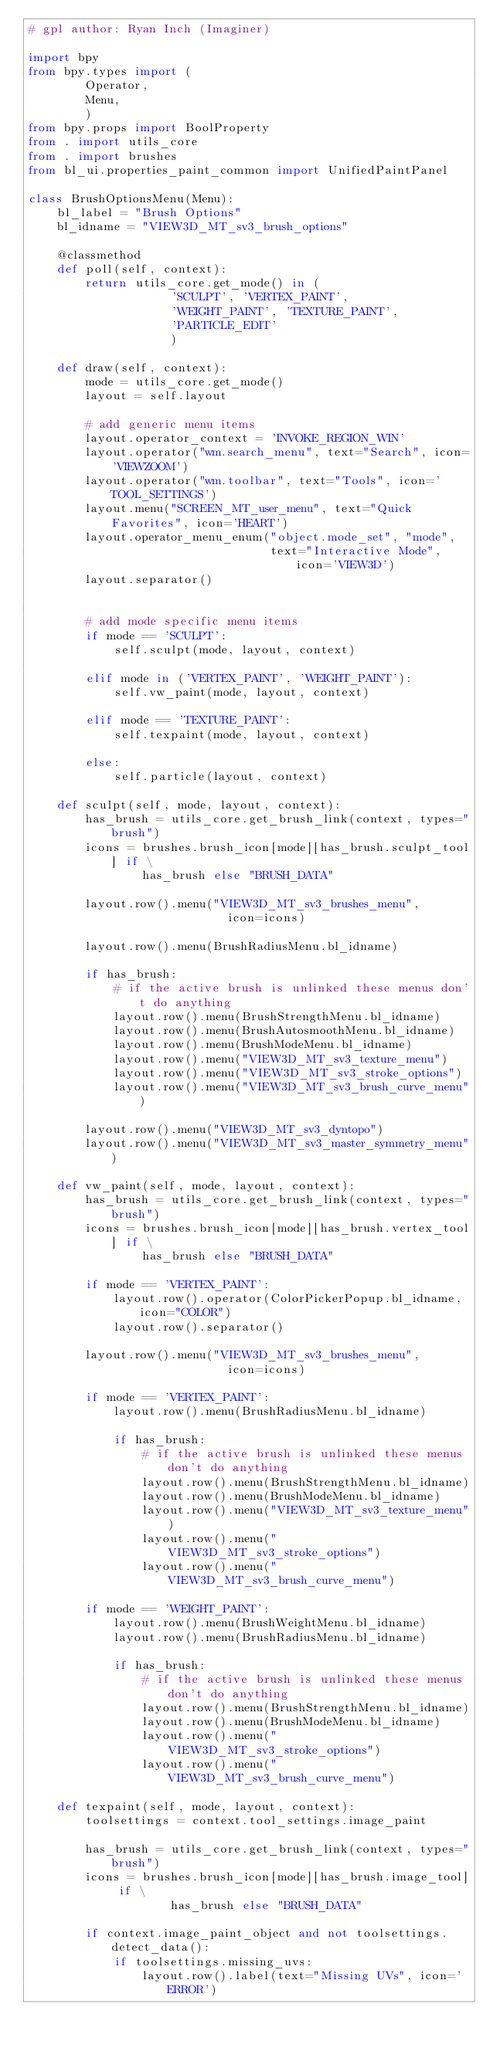<code> <loc_0><loc_0><loc_500><loc_500><_Python_># gpl author: Ryan Inch (Imaginer)

import bpy
from bpy.types import (
        Operator,
        Menu,
        )
from bpy.props import BoolProperty
from . import utils_core
from . import brushes
from bl_ui.properties_paint_common import UnifiedPaintPanel

class BrushOptionsMenu(Menu):
    bl_label = "Brush Options"
    bl_idname = "VIEW3D_MT_sv3_brush_options"

    @classmethod
    def poll(self, context):
        return utils_core.get_mode() in (
                    'SCULPT', 'VERTEX_PAINT',
                    'WEIGHT_PAINT', 'TEXTURE_PAINT',
                    'PARTICLE_EDIT'
                    )

    def draw(self, context):
        mode = utils_core.get_mode()
        layout = self.layout
        
        # add generic menu items
        layout.operator_context = 'INVOKE_REGION_WIN'
        layout.operator("wm.search_menu", text="Search", icon='VIEWZOOM')
        layout.operator("wm.toolbar", text="Tools", icon='TOOL_SETTINGS')
        layout.menu("SCREEN_MT_user_menu", text="Quick Favorites", icon='HEART')
        layout.operator_menu_enum("object.mode_set", "mode",
                                  text="Interactive Mode", icon='VIEW3D')
        layout.separator()
        
        
        # add mode specific menu items
        if mode == 'SCULPT':
            self.sculpt(mode, layout, context)

        elif mode in ('VERTEX_PAINT', 'WEIGHT_PAINT'):
            self.vw_paint(mode, layout, context)

        elif mode == 'TEXTURE_PAINT':
            self.texpaint(mode, layout, context)

        else:
            self.particle(layout, context)

    def sculpt(self, mode, layout, context):
        has_brush = utils_core.get_brush_link(context, types="brush")
        icons = brushes.brush_icon[mode][has_brush.sculpt_tool] if \
                has_brush else "BRUSH_DATA"
        
        layout.row().menu("VIEW3D_MT_sv3_brushes_menu",
                            icon=icons)

        layout.row().menu(BrushRadiusMenu.bl_idname)

        if has_brush:
            # if the active brush is unlinked these menus don't do anything
            layout.row().menu(BrushStrengthMenu.bl_idname)
            layout.row().menu(BrushAutosmoothMenu.bl_idname)
            layout.row().menu(BrushModeMenu.bl_idname)
            layout.row().menu("VIEW3D_MT_sv3_texture_menu")
            layout.row().menu("VIEW3D_MT_sv3_stroke_options")
            layout.row().menu("VIEW3D_MT_sv3_brush_curve_menu")

        layout.row().menu("VIEW3D_MT_sv3_dyntopo")
        layout.row().menu("VIEW3D_MT_sv3_master_symmetry_menu")

    def vw_paint(self, mode, layout, context):
        has_brush = utils_core.get_brush_link(context, types="brush")
        icons = brushes.brush_icon[mode][has_brush.vertex_tool] if \
                has_brush else "BRUSH_DATA"
        
        if mode == 'VERTEX_PAINT':		
            layout.row().operator(ColorPickerPopup.bl_idname, icon="COLOR")
            layout.row().separator()

        layout.row().menu("VIEW3D_MT_sv3_brushes_menu",
                            icon=icons)

        if mode == 'VERTEX_PAINT':
            layout.row().menu(BrushRadiusMenu.bl_idname)

            if has_brush:
                # if the active brush is unlinked these menus don't do anything
                layout.row().menu(BrushStrengthMenu.bl_idname)
                layout.row().menu(BrushModeMenu.bl_idname)
                layout.row().menu("VIEW3D_MT_sv3_texture_menu")
                layout.row().menu("VIEW3D_MT_sv3_stroke_options")
                layout.row().menu("VIEW3D_MT_sv3_brush_curve_menu")

        if mode == 'WEIGHT_PAINT':
            layout.row().menu(BrushWeightMenu.bl_idname)
            layout.row().menu(BrushRadiusMenu.bl_idname)

            if has_brush:
                # if the active brush is unlinked these menus don't do anything
                layout.row().menu(BrushStrengthMenu.bl_idname)
                layout.row().menu(BrushModeMenu.bl_idname)
                layout.row().menu("VIEW3D_MT_sv3_stroke_options")
                layout.row().menu("VIEW3D_MT_sv3_brush_curve_menu")

    def texpaint(self, mode, layout, context):
        toolsettings = context.tool_settings.image_paint
        
        has_brush = utils_core.get_brush_link(context, types="brush")
        icons = brushes.brush_icon[mode][has_brush.image_tool] if \
                    has_brush else "BRUSH_DATA"

        if context.image_paint_object and not toolsettings.detect_data():
            if toolsettings.missing_uvs:
                layout.row().label(text="Missing UVs", icon='ERROR')</code> 